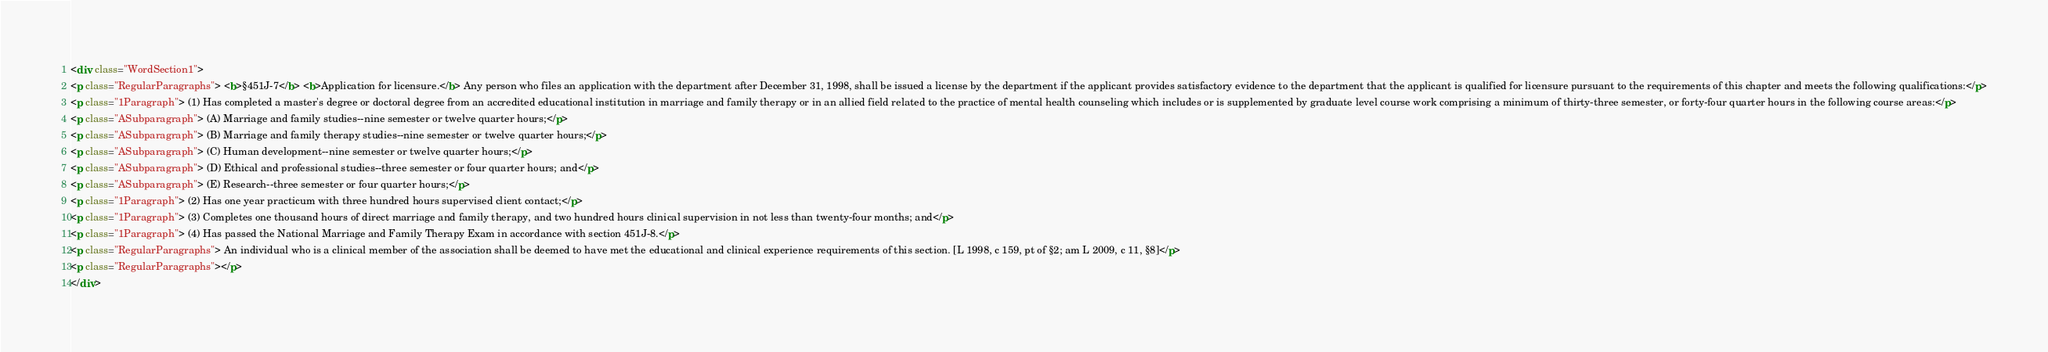Convert code to text. <code><loc_0><loc_0><loc_500><loc_500><_HTML_><div class="WordSection1">
<p class="RegularParagraphs"> <b>§451J-7</b> <b>Application for licensure.</b> Any person who files an application with the department after December 31, 1998, shall be issued a license by the department if the applicant provides satisfactory evidence to the department that the applicant is qualified for licensure pursuant to the requirements of this chapter and meets the following qualifications:</p>
<p class="1Paragraph"> (1) Has completed a master's degree or doctoral degree from an accredited educational institution in marriage and family therapy or in an allied field related to the practice of mental health counseling which includes or is supplemented by graduate level course work comprising a minimum of thirty-three semester, or forty-four quarter hours in the following course areas:</p>
<p class="ASubparagraph"> (A) Marriage and family studies--nine semester or twelve quarter hours;</p>
<p class="ASubparagraph"> (B) Marriage and family therapy studies--nine semester or twelve quarter hours;</p>
<p class="ASubparagraph"> (C) Human development--nine semester or twelve quarter hours;</p>
<p class="ASubparagraph"> (D) Ethical and professional studies--three semester or four quarter hours; and</p>
<p class="ASubparagraph"> (E) Research--three semester or four quarter hours;</p>
<p class="1Paragraph"> (2) Has one year practicum with three hundred hours supervised client contact;</p>
<p class="1Paragraph"> (3) Completes one thousand hours of direct marriage and family therapy, and two hundred hours clinical supervision in not less than twenty-four months; and</p>
<p class="1Paragraph"> (4) Has passed the National Marriage and Family Therapy Exam in accordance with section 451J-8.</p>
<p class="RegularParagraphs"> An individual who is a clinical member of the association shall be deemed to have met the educational and clinical experience requirements of this section. [L 1998, c 159, pt of §2; am L 2009, c 11, §8]</p>
<p class="RegularParagraphs"></p>
</div></code> 